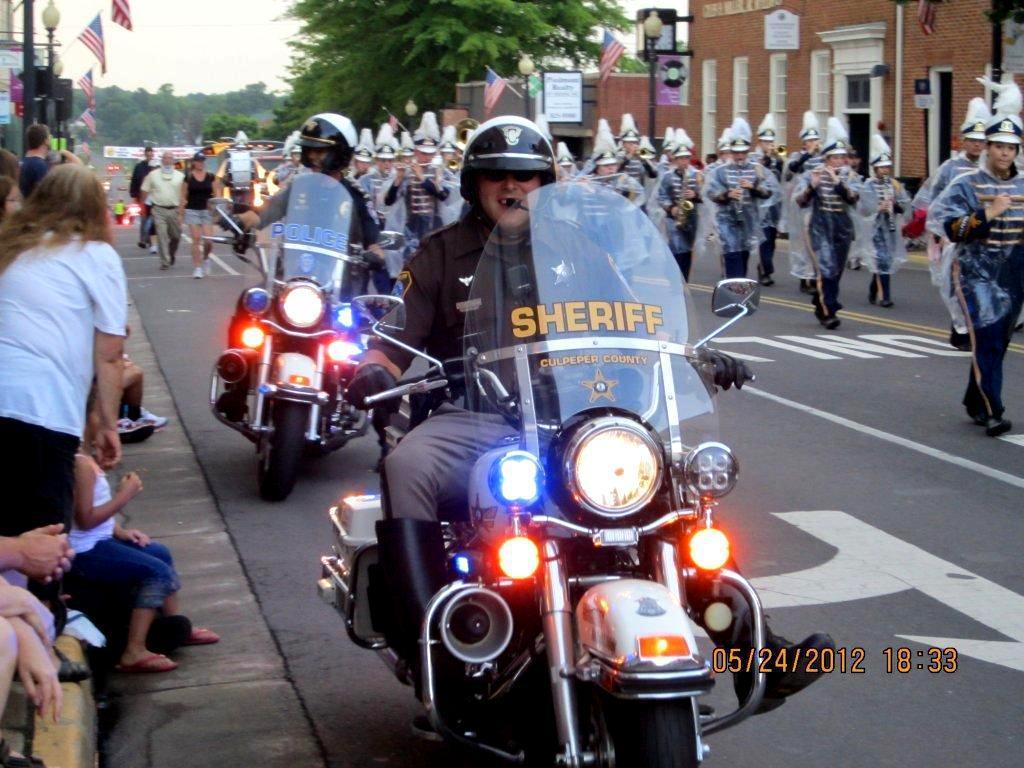Can you describe this image briefly? Two persons are sitting on bike with helmet , goggles. On the bike tire lights. It is on the road. On the right side a group of people are marching, also there are buildings, street poles, flags, and trees on the right side. On the left side some people are standing. In the background there are trees, sky. 